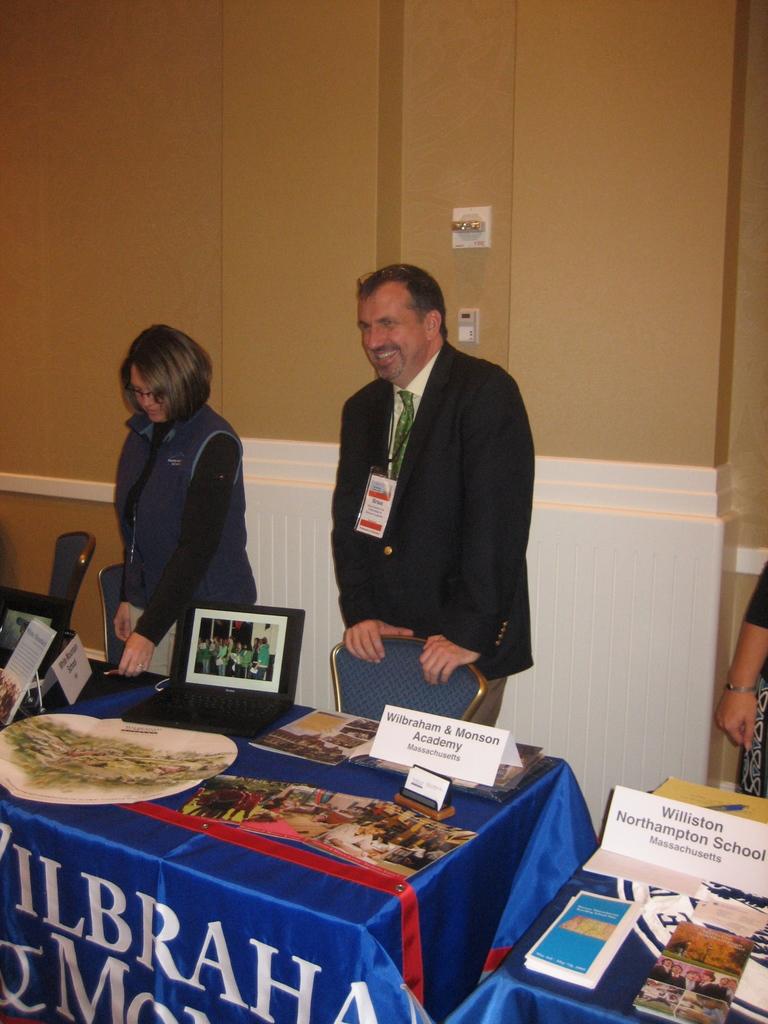What is the name of the academy?
Give a very brief answer. Wilbraham & monson. 